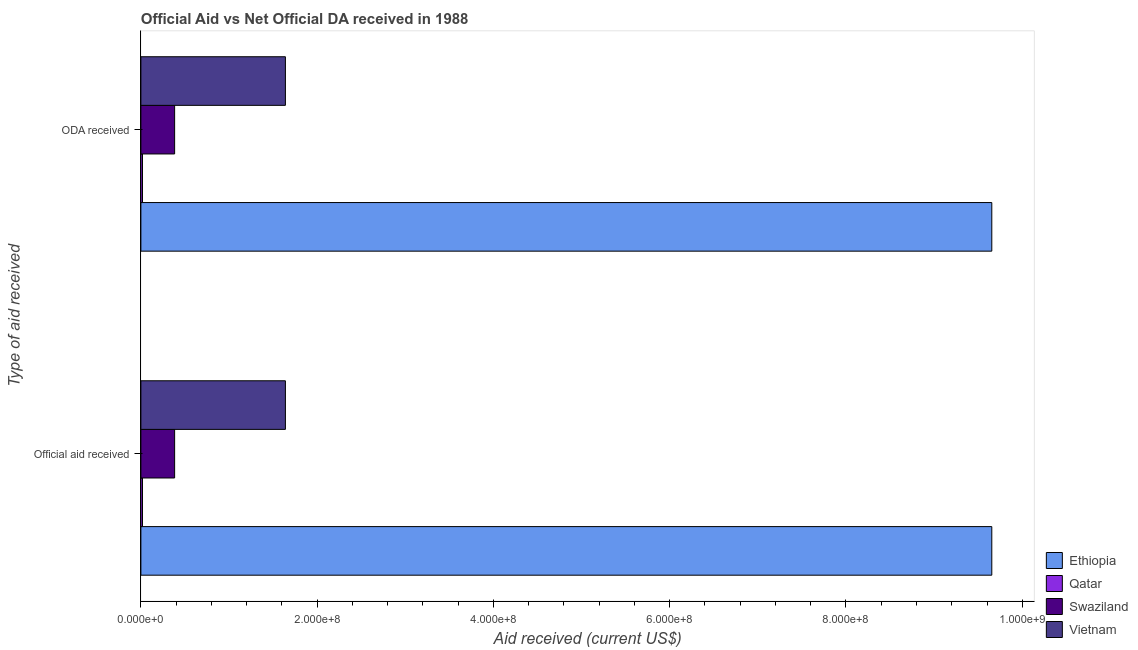How many groups of bars are there?
Make the answer very short. 2. Are the number of bars per tick equal to the number of legend labels?
Your answer should be very brief. Yes. How many bars are there on the 2nd tick from the top?
Give a very brief answer. 4. What is the label of the 1st group of bars from the top?
Your answer should be compact. ODA received. What is the oda received in Swaziland?
Ensure brevity in your answer.  3.83e+07. Across all countries, what is the maximum official aid received?
Provide a short and direct response. 9.65e+08. Across all countries, what is the minimum oda received?
Keep it short and to the point. 1.83e+06. In which country was the official aid received maximum?
Give a very brief answer. Ethiopia. In which country was the oda received minimum?
Offer a terse response. Qatar. What is the total oda received in the graph?
Give a very brief answer. 1.17e+09. What is the difference between the official aid received in Swaziland and that in Ethiopia?
Make the answer very short. -9.27e+08. What is the difference between the official aid received in Swaziland and the oda received in Vietnam?
Provide a short and direct response. -1.26e+08. What is the average oda received per country?
Your response must be concise. 2.92e+08. What is the difference between the oda received and official aid received in Swaziland?
Your answer should be compact. 0. In how many countries, is the official aid received greater than 80000000 US$?
Provide a succinct answer. 2. What is the ratio of the official aid received in Qatar to that in Ethiopia?
Your response must be concise. 0. In how many countries, is the official aid received greater than the average official aid received taken over all countries?
Keep it short and to the point. 1. What does the 3rd bar from the top in Official aid received represents?
Provide a succinct answer. Qatar. What does the 1st bar from the bottom in ODA received represents?
Give a very brief answer. Ethiopia. How many bars are there?
Give a very brief answer. 8. How many countries are there in the graph?
Ensure brevity in your answer.  4. Where does the legend appear in the graph?
Provide a succinct answer. Bottom right. What is the title of the graph?
Give a very brief answer. Official Aid vs Net Official DA received in 1988 . What is the label or title of the X-axis?
Provide a short and direct response. Aid received (current US$). What is the label or title of the Y-axis?
Provide a short and direct response. Type of aid received. What is the Aid received (current US$) in Ethiopia in Official aid received?
Your answer should be compact. 9.65e+08. What is the Aid received (current US$) in Qatar in Official aid received?
Your response must be concise. 1.83e+06. What is the Aid received (current US$) of Swaziland in Official aid received?
Make the answer very short. 3.83e+07. What is the Aid received (current US$) of Vietnam in Official aid received?
Your answer should be compact. 1.64e+08. What is the Aid received (current US$) in Ethiopia in ODA received?
Ensure brevity in your answer.  9.65e+08. What is the Aid received (current US$) in Qatar in ODA received?
Offer a very short reply. 1.83e+06. What is the Aid received (current US$) of Swaziland in ODA received?
Provide a succinct answer. 3.83e+07. What is the Aid received (current US$) of Vietnam in ODA received?
Your answer should be compact. 1.64e+08. Across all Type of aid received, what is the maximum Aid received (current US$) of Ethiopia?
Provide a short and direct response. 9.65e+08. Across all Type of aid received, what is the maximum Aid received (current US$) in Qatar?
Offer a very short reply. 1.83e+06. Across all Type of aid received, what is the maximum Aid received (current US$) of Swaziland?
Provide a short and direct response. 3.83e+07. Across all Type of aid received, what is the maximum Aid received (current US$) of Vietnam?
Offer a terse response. 1.64e+08. Across all Type of aid received, what is the minimum Aid received (current US$) of Ethiopia?
Make the answer very short. 9.65e+08. Across all Type of aid received, what is the minimum Aid received (current US$) in Qatar?
Make the answer very short. 1.83e+06. Across all Type of aid received, what is the minimum Aid received (current US$) of Swaziland?
Your response must be concise. 3.83e+07. Across all Type of aid received, what is the minimum Aid received (current US$) in Vietnam?
Your answer should be very brief. 1.64e+08. What is the total Aid received (current US$) of Ethiopia in the graph?
Your answer should be compact. 1.93e+09. What is the total Aid received (current US$) of Qatar in the graph?
Your answer should be compact. 3.66e+06. What is the total Aid received (current US$) of Swaziland in the graph?
Your answer should be compact. 7.65e+07. What is the total Aid received (current US$) in Vietnam in the graph?
Offer a terse response. 3.28e+08. What is the difference between the Aid received (current US$) of Ethiopia in Official aid received and that in ODA received?
Your answer should be very brief. 0. What is the difference between the Aid received (current US$) of Ethiopia in Official aid received and the Aid received (current US$) of Qatar in ODA received?
Your answer should be very brief. 9.64e+08. What is the difference between the Aid received (current US$) in Ethiopia in Official aid received and the Aid received (current US$) in Swaziland in ODA received?
Give a very brief answer. 9.27e+08. What is the difference between the Aid received (current US$) in Ethiopia in Official aid received and the Aid received (current US$) in Vietnam in ODA received?
Make the answer very short. 8.01e+08. What is the difference between the Aid received (current US$) in Qatar in Official aid received and the Aid received (current US$) in Swaziland in ODA received?
Your response must be concise. -3.64e+07. What is the difference between the Aid received (current US$) of Qatar in Official aid received and the Aid received (current US$) of Vietnam in ODA received?
Ensure brevity in your answer.  -1.62e+08. What is the difference between the Aid received (current US$) of Swaziland in Official aid received and the Aid received (current US$) of Vietnam in ODA received?
Keep it short and to the point. -1.26e+08. What is the average Aid received (current US$) of Ethiopia per Type of aid received?
Make the answer very short. 9.65e+08. What is the average Aid received (current US$) in Qatar per Type of aid received?
Provide a succinct answer. 1.83e+06. What is the average Aid received (current US$) in Swaziland per Type of aid received?
Your response must be concise. 3.83e+07. What is the average Aid received (current US$) in Vietnam per Type of aid received?
Offer a terse response. 1.64e+08. What is the difference between the Aid received (current US$) in Ethiopia and Aid received (current US$) in Qatar in Official aid received?
Offer a very short reply. 9.64e+08. What is the difference between the Aid received (current US$) of Ethiopia and Aid received (current US$) of Swaziland in Official aid received?
Your answer should be very brief. 9.27e+08. What is the difference between the Aid received (current US$) of Ethiopia and Aid received (current US$) of Vietnam in Official aid received?
Make the answer very short. 8.01e+08. What is the difference between the Aid received (current US$) of Qatar and Aid received (current US$) of Swaziland in Official aid received?
Keep it short and to the point. -3.64e+07. What is the difference between the Aid received (current US$) in Qatar and Aid received (current US$) in Vietnam in Official aid received?
Your response must be concise. -1.62e+08. What is the difference between the Aid received (current US$) of Swaziland and Aid received (current US$) of Vietnam in Official aid received?
Keep it short and to the point. -1.26e+08. What is the difference between the Aid received (current US$) of Ethiopia and Aid received (current US$) of Qatar in ODA received?
Give a very brief answer. 9.64e+08. What is the difference between the Aid received (current US$) of Ethiopia and Aid received (current US$) of Swaziland in ODA received?
Your response must be concise. 9.27e+08. What is the difference between the Aid received (current US$) in Ethiopia and Aid received (current US$) in Vietnam in ODA received?
Ensure brevity in your answer.  8.01e+08. What is the difference between the Aid received (current US$) in Qatar and Aid received (current US$) in Swaziland in ODA received?
Offer a very short reply. -3.64e+07. What is the difference between the Aid received (current US$) of Qatar and Aid received (current US$) of Vietnam in ODA received?
Your answer should be very brief. -1.62e+08. What is the difference between the Aid received (current US$) of Swaziland and Aid received (current US$) of Vietnam in ODA received?
Offer a very short reply. -1.26e+08. What is the ratio of the Aid received (current US$) in Ethiopia in Official aid received to that in ODA received?
Offer a very short reply. 1. What is the ratio of the Aid received (current US$) of Vietnam in Official aid received to that in ODA received?
Ensure brevity in your answer.  1. What is the difference between the highest and the second highest Aid received (current US$) of Swaziland?
Keep it short and to the point. 0. What is the difference between the highest and the lowest Aid received (current US$) in Qatar?
Provide a short and direct response. 0. What is the difference between the highest and the lowest Aid received (current US$) in Vietnam?
Provide a short and direct response. 0. 